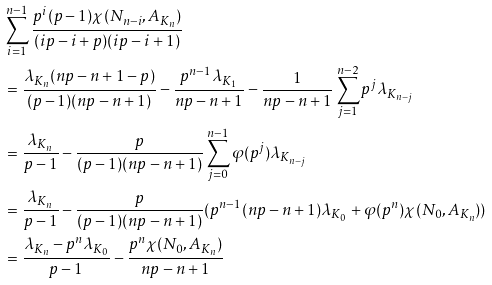Convert formula to latex. <formula><loc_0><loc_0><loc_500><loc_500>& \sum _ { i = 1 } ^ { n - 1 } \frac { p ^ { i } ( p - 1 ) \chi ( N _ { n - i } , A _ { K _ { n } } ) } { ( i p - i + p ) ( i p - i + 1 ) } \\ & = \frac { \lambda _ { K _ { n } } ( n p - n + 1 - p ) } { ( p - 1 ) ( n p - n + 1 ) } - \frac { p ^ { n - 1 } \lambda _ { K _ { 1 } } } { n p - n + 1 } - \frac { 1 } { n p - n + 1 } \sum _ { j = 1 } ^ { n - 2 } p ^ { j } \lambda _ { K _ { n - j } } \\ & = \frac { \lambda _ { K _ { n } } } { p - 1 } - \frac { p } { ( p - 1 ) ( n p - n + 1 ) } \sum _ { j = 0 } ^ { n - 1 } \varphi ( p ^ { j } ) \lambda _ { K _ { n - j } } \\ & = \frac { \lambda _ { K _ { n } } } { p - 1 } - \frac { p } { ( p - 1 ) ( n p - n + 1 ) } ( p ^ { n - 1 } ( n p - n + 1 ) \lambda _ { K _ { 0 } } + \varphi ( p ^ { n } ) \chi ( N _ { 0 } , A _ { K _ { n } } ) ) \\ & = \frac { \lambda _ { K _ { n } } - p ^ { n } \lambda _ { K _ { 0 } } } { p - 1 } - \frac { p ^ { n } \chi ( N _ { 0 } , A _ { K _ { n } } ) } { n p - n + 1 }</formula> 